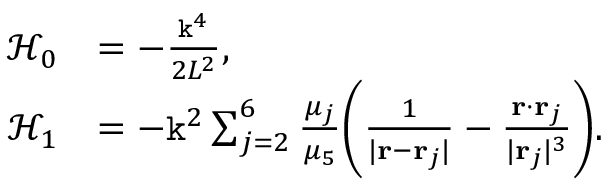<formula> <loc_0><loc_0><loc_500><loc_500>\begin{array} { r l } { \mathcal { H } _ { 0 } } & { = - \frac { k ^ { 4 } } { 2 L ^ { 2 } } , } \\ { \mathcal { H } _ { 1 } } & { = - k ^ { 2 } \sum _ { j = 2 } ^ { 6 } \frac { \mu _ { j } } { \mu _ { 5 } } \left ( \frac { 1 } { | r - r _ { j } | } - \frac { r \cdot r _ { j } } { | r _ { j } | ^ { 3 } } \right ) . } \end{array}</formula> 